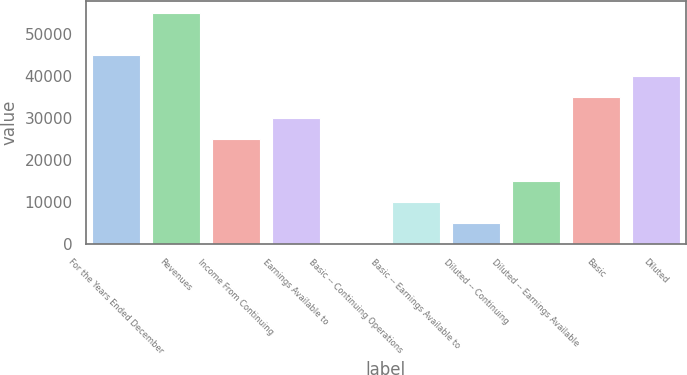<chart> <loc_0><loc_0><loc_500><loc_500><bar_chart><fcel>For the Years Ended December<fcel>Revenues<fcel>Income From Continuing<fcel>Earnings Available to<fcel>Basic -­ Continuing Operations<fcel>Basic -­ Earnings Available to<fcel>Diluted -­ Continuing<fcel>Diluted -­ Earnings Available<fcel>Basic<fcel>Diluted<nl><fcel>45052.3<fcel>55063.7<fcel>25029.5<fcel>30035.2<fcel>0.9<fcel>10012.3<fcel>5006.61<fcel>15018<fcel>35040.9<fcel>40046.6<nl></chart> 